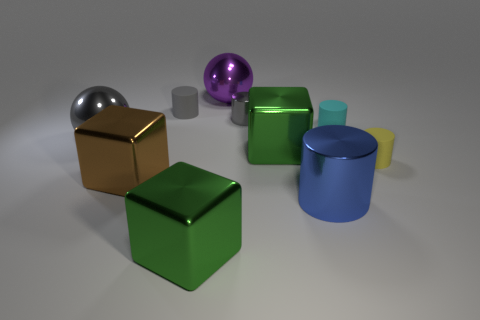Subtract 1 cylinders. How many cylinders are left? 4 Subtract all blue cylinders. How many cylinders are left? 4 Subtract all gray metal cylinders. How many cylinders are left? 4 Subtract all purple cylinders. Subtract all brown spheres. How many cylinders are left? 5 Subtract all spheres. How many objects are left? 8 Subtract all big green metallic objects. Subtract all large metallic cylinders. How many objects are left? 7 Add 6 large gray objects. How many large gray objects are left? 7 Add 3 blue matte blocks. How many blue matte blocks exist? 3 Subtract 0 red cylinders. How many objects are left? 10 